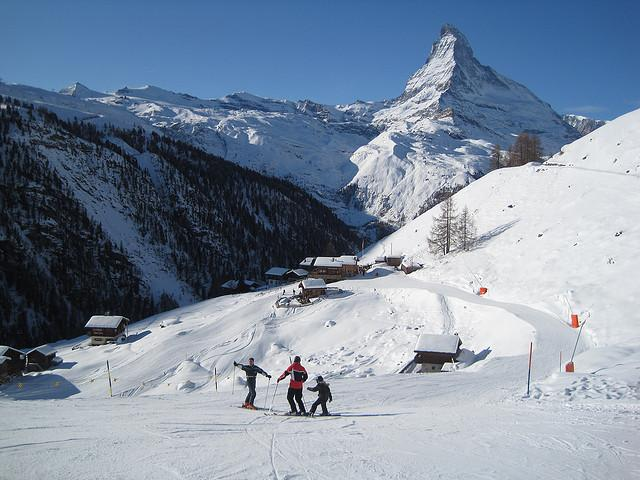What types of trees are these?

Choices:
A) eucalyptus
B) birches
C) evergreens
D) oaks evergreens 